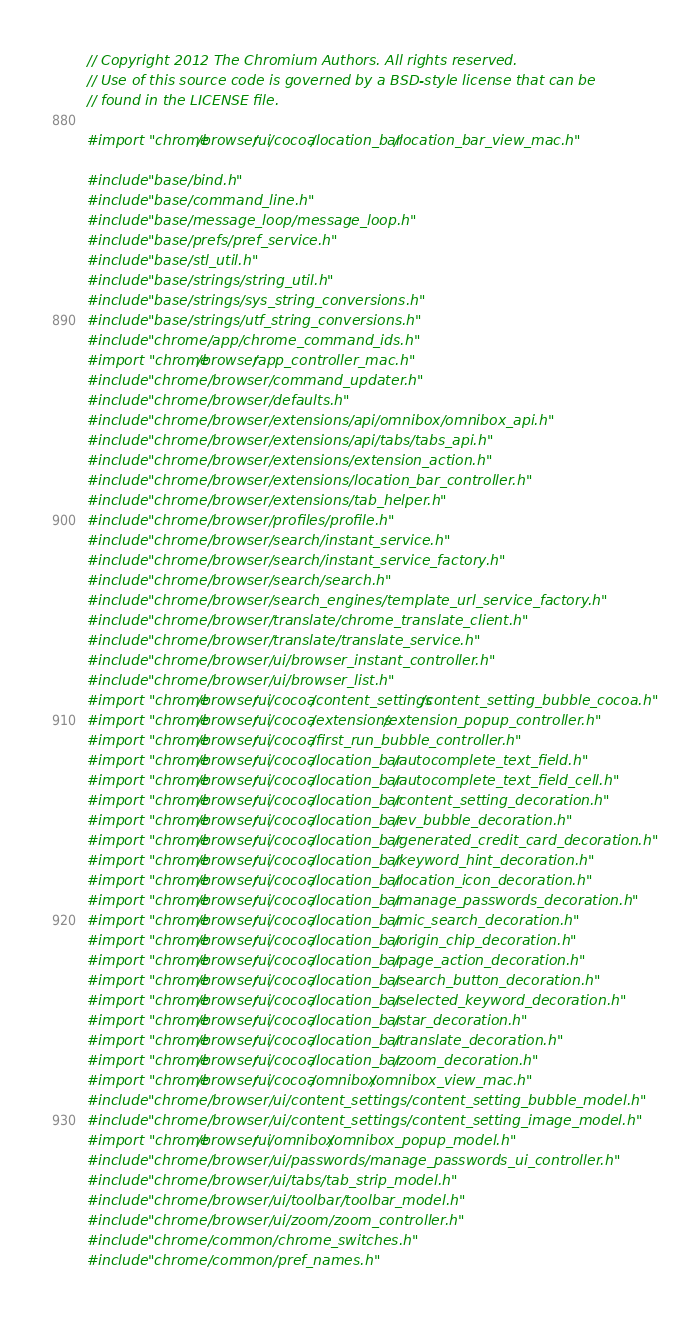<code> <loc_0><loc_0><loc_500><loc_500><_ObjectiveC_>// Copyright 2012 The Chromium Authors. All rights reserved.
// Use of this source code is governed by a BSD-style license that can be
// found in the LICENSE file.

#import "chrome/browser/ui/cocoa/location_bar/location_bar_view_mac.h"

#include "base/bind.h"
#include "base/command_line.h"
#include "base/message_loop/message_loop.h"
#include "base/prefs/pref_service.h"
#include "base/stl_util.h"
#include "base/strings/string_util.h"
#include "base/strings/sys_string_conversions.h"
#include "base/strings/utf_string_conversions.h"
#include "chrome/app/chrome_command_ids.h"
#import "chrome/browser/app_controller_mac.h"
#include "chrome/browser/command_updater.h"
#include "chrome/browser/defaults.h"
#include "chrome/browser/extensions/api/omnibox/omnibox_api.h"
#include "chrome/browser/extensions/api/tabs/tabs_api.h"
#include "chrome/browser/extensions/extension_action.h"
#include "chrome/browser/extensions/location_bar_controller.h"
#include "chrome/browser/extensions/tab_helper.h"
#include "chrome/browser/profiles/profile.h"
#include "chrome/browser/search/instant_service.h"
#include "chrome/browser/search/instant_service_factory.h"
#include "chrome/browser/search/search.h"
#include "chrome/browser/search_engines/template_url_service_factory.h"
#include "chrome/browser/translate/chrome_translate_client.h"
#include "chrome/browser/translate/translate_service.h"
#include "chrome/browser/ui/browser_instant_controller.h"
#include "chrome/browser/ui/browser_list.h"
#import "chrome/browser/ui/cocoa/content_settings/content_setting_bubble_cocoa.h"
#import "chrome/browser/ui/cocoa/extensions/extension_popup_controller.h"
#import "chrome/browser/ui/cocoa/first_run_bubble_controller.h"
#import "chrome/browser/ui/cocoa/location_bar/autocomplete_text_field.h"
#import "chrome/browser/ui/cocoa/location_bar/autocomplete_text_field_cell.h"
#import "chrome/browser/ui/cocoa/location_bar/content_setting_decoration.h"
#import "chrome/browser/ui/cocoa/location_bar/ev_bubble_decoration.h"
#import "chrome/browser/ui/cocoa/location_bar/generated_credit_card_decoration.h"
#import "chrome/browser/ui/cocoa/location_bar/keyword_hint_decoration.h"
#import "chrome/browser/ui/cocoa/location_bar/location_icon_decoration.h"
#import "chrome/browser/ui/cocoa/location_bar/manage_passwords_decoration.h"
#import "chrome/browser/ui/cocoa/location_bar/mic_search_decoration.h"
#import "chrome/browser/ui/cocoa/location_bar/origin_chip_decoration.h"
#import "chrome/browser/ui/cocoa/location_bar/page_action_decoration.h"
#import "chrome/browser/ui/cocoa/location_bar/search_button_decoration.h"
#import "chrome/browser/ui/cocoa/location_bar/selected_keyword_decoration.h"
#import "chrome/browser/ui/cocoa/location_bar/star_decoration.h"
#import "chrome/browser/ui/cocoa/location_bar/translate_decoration.h"
#import "chrome/browser/ui/cocoa/location_bar/zoom_decoration.h"
#import "chrome/browser/ui/cocoa/omnibox/omnibox_view_mac.h"
#include "chrome/browser/ui/content_settings/content_setting_bubble_model.h"
#include "chrome/browser/ui/content_settings/content_setting_image_model.h"
#import "chrome/browser/ui/omnibox/omnibox_popup_model.h"
#include "chrome/browser/ui/passwords/manage_passwords_ui_controller.h"
#include "chrome/browser/ui/tabs/tab_strip_model.h"
#include "chrome/browser/ui/toolbar/toolbar_model.h"
#include "chrome/browser/ui/zoom/zoom_controller.h"
#include "chrome/common/chrome_switches.h"
#include "chrome/common/pref_names.h"</code> 